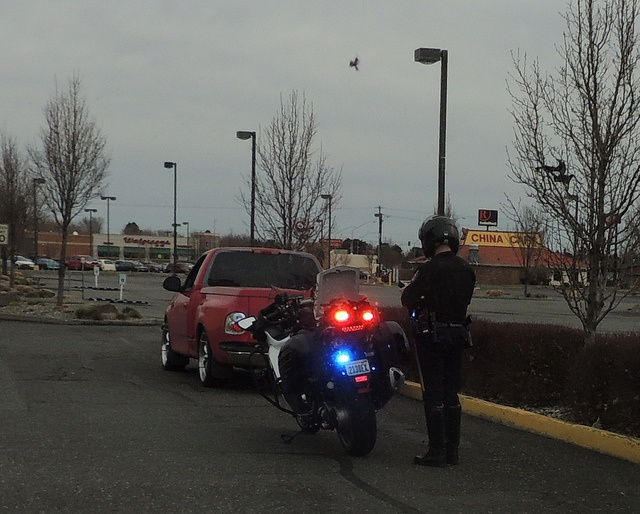Describe the objects in this image and their specific colors. I can see motorcycle in darkgray, black, gray, maroon, and navy tones, truck in darkgray, black, maroon, and gray tones, people in darkgray, black, and gray tones, truck in darkgray, black, maroon, and gray tones, and car in darkgray, black, and gray tones in this image. 